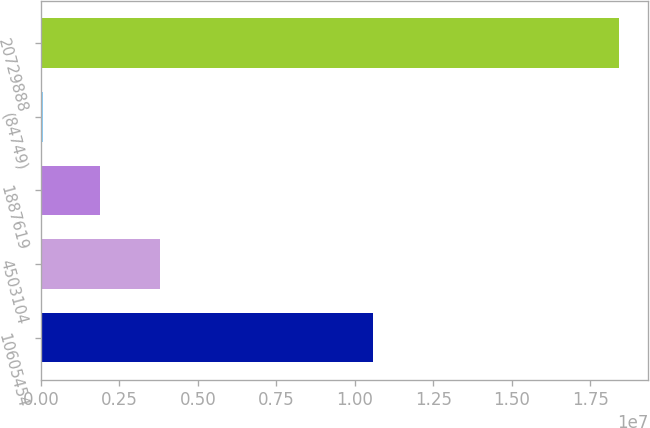Convert chart to OTSL. <chart><loc_0><loc_0><loc_500><loc_500><bar_chart><fcel>10605454<fcel>4503104<fcel>1887619<fcel>(84749)<fcel>20729888<nl><fcel>1.05683e+07<fcel>3.78565e+06<fcel>1.89218e+06<fcel>55196<fcel>1.8425e+07<nl></chart> 